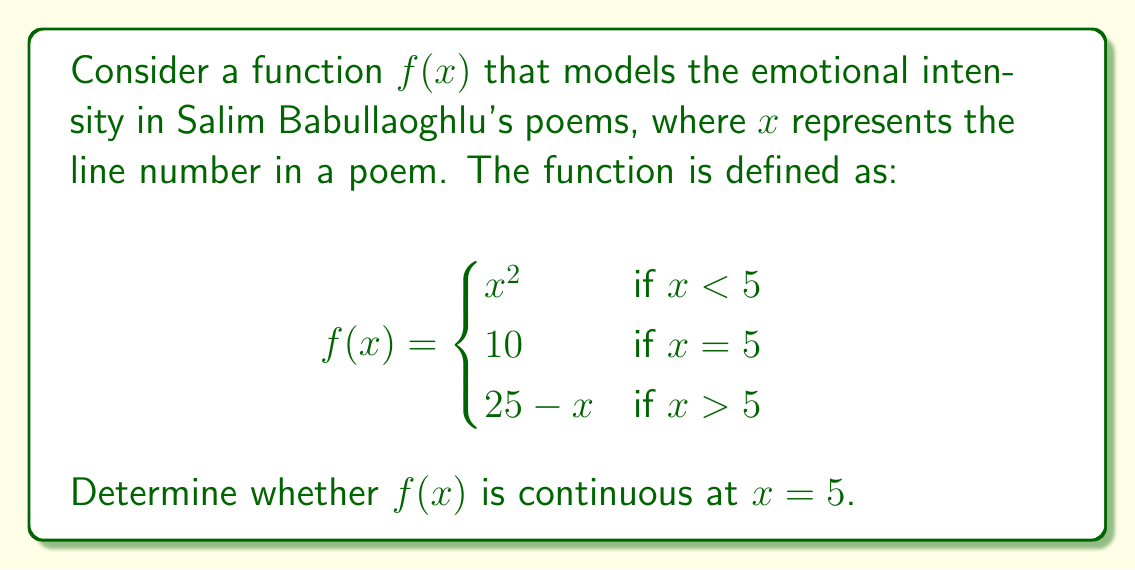Solve this math problem. To determine if the function $f(x)$ is continuous at $x = 5$, we need to check three conditions:

1. $f(x)$ is defined at $x = 5$
2. $\lim_{x \to 5^-} f(x)$ exists
3. $\lim_{x \to 5^+} f(x)$ exists
4. $\lim_{x \to 5^-} f(x) = \lim_{x \to 5^+} f(x) = f(5)$

Let's check each condition:

1. $f(5)$ is defined and equals 10.

2. $\lim_{x \to 5^-} f(x) = \lim_{x \to 5^-} x^2 = 5^2 = 25$

3. $\lim_{x \to 5^+} f(x) = \lim_{x \to 5^+} (25 - x) = 25 - 5 = 20$

4. Comparing the limits and the function value:
   $\lim_{x \to 5^-} f(x) = 25$
   $\lim_{x \to 5^+} f(x) = 20$
   $f(5) = 10$

Since the left-hand limit, right-hand limit, and the function value at $x = 5$ are all different, the function is not continuous at $x = 5$.

This discontinuity could represent a sudden shift in emotional intensity in Babullaoghlu's poem at the fifth line, perhaps signifying a dramatic turn in the poem's mood or theme.
Answer: The function $f(x)$ is not continuous at $x = 5$. 